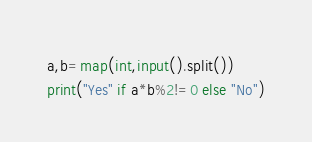<code> <loc_0><loc_0><loc_500><loc_500><_Python_>a,b=map(int,input().split())
print("Yes" if a*b%2!=0 else "No")</code> 